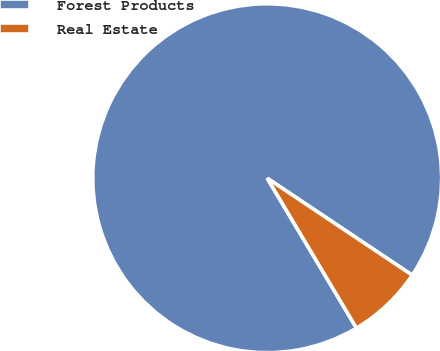<chart> <loc_0><loc_0><loc_500><loc_500><pie_chart><fcel>Forest Products<fcel>Real Estate<nl><fcel>92.93%<fcel>7.07%<nl></chart> 